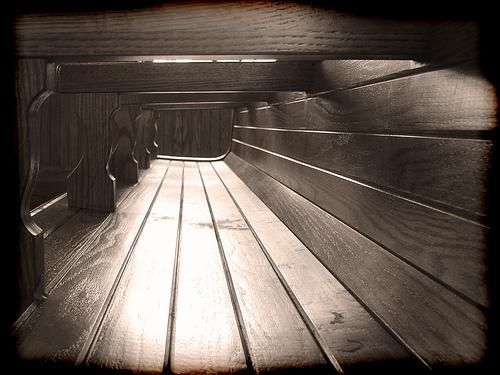Question: how many seats are shown?
Choices:
A. 1.
B. 2.
C. 3.
D. 5.
Answer with the letter. Answer: D Question: where is this shot?
Choices:
A. Sidewalk.
B. Car.
C. Airplane.
D. Bench.
Answer with the letter. Answer: D 